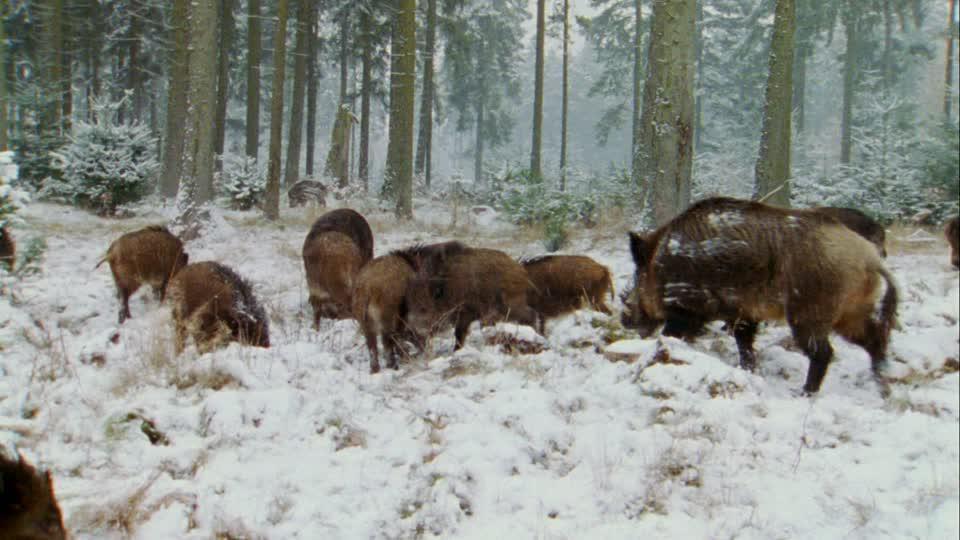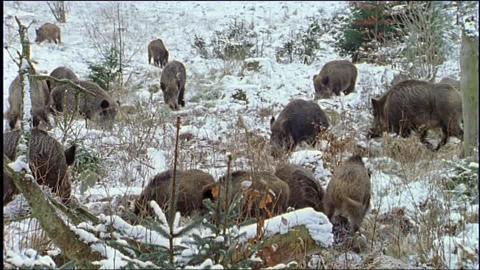The first image is the image on the left, the second image is the image on the right. For the images shown, is this caption "There is at most three wild pigs in the right image." true? Answer yes or no. No. The first image is the image on the left, the second image is the image on the right. Analyze the images presented: Is the assertion "There are no more than three brown boars in the grass." valid? Answer yes or no. No. 